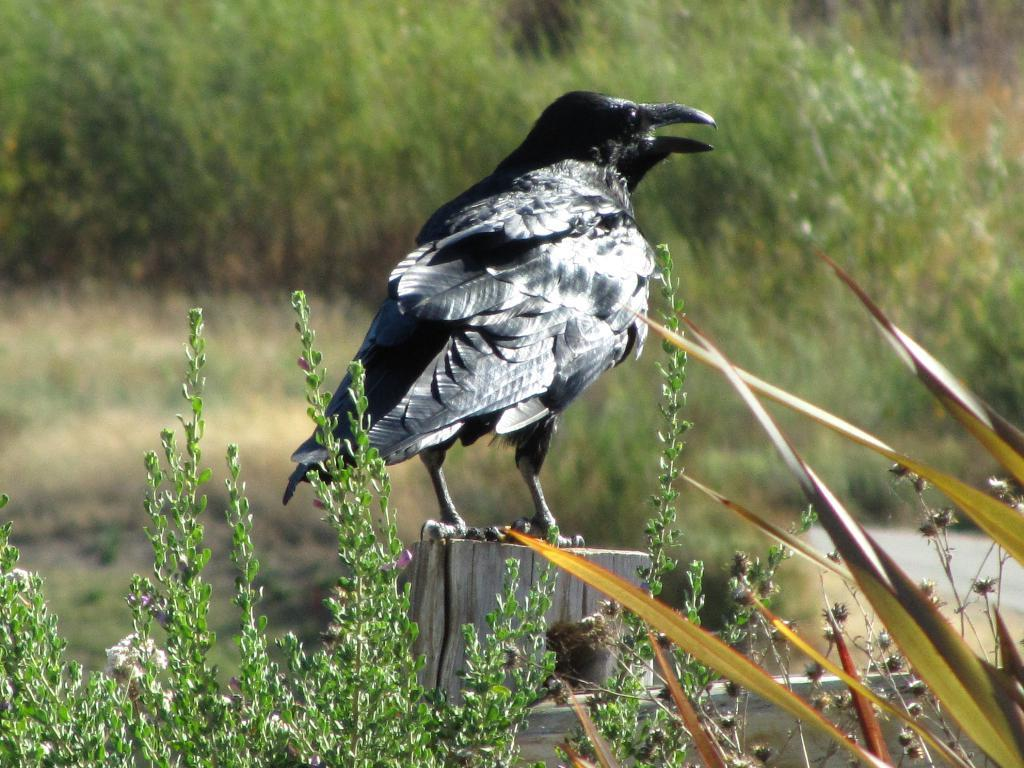What is the main subject of the image? There is a bird on a wooden surface in the image. What else can be seen in the image besides the bird? Plants are visible in the image. What color is predominant in the background of the image? The background of the image is green. What type of payment does the bird offer to the lawyer in the image? There is no lawyer or payment present in the image; it features a bird on a wooden surface and plants in the background. 